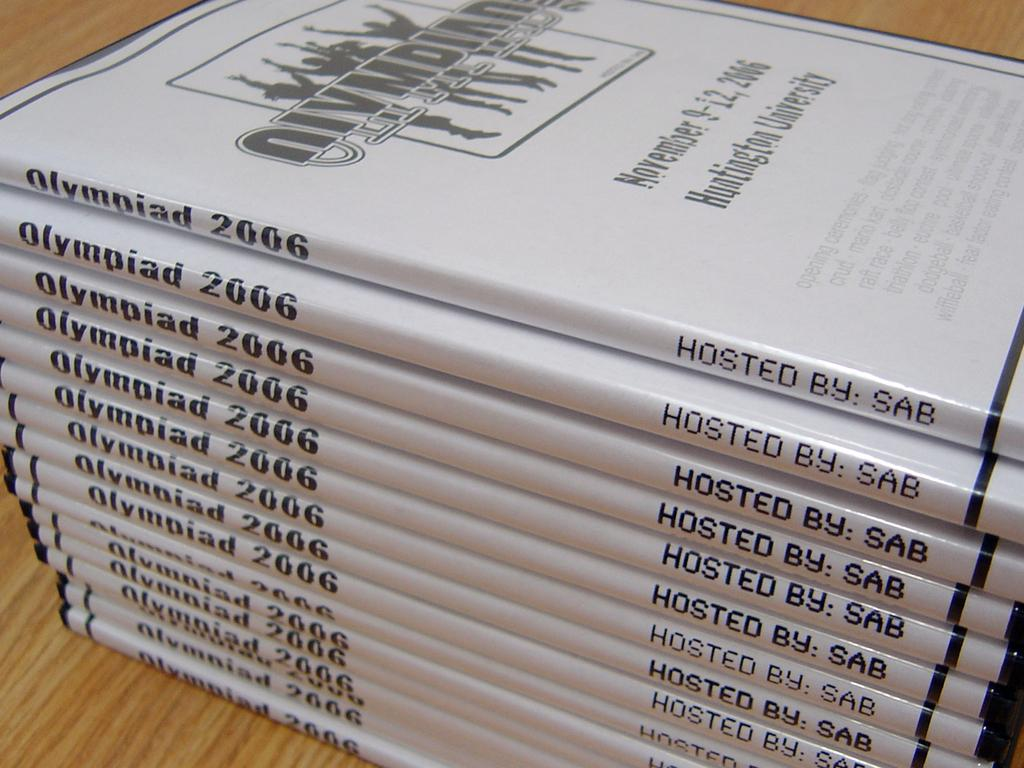<image>
Give a short and clear explanation of the subsequent image. A stack of the same book named Olympiad 2006. 